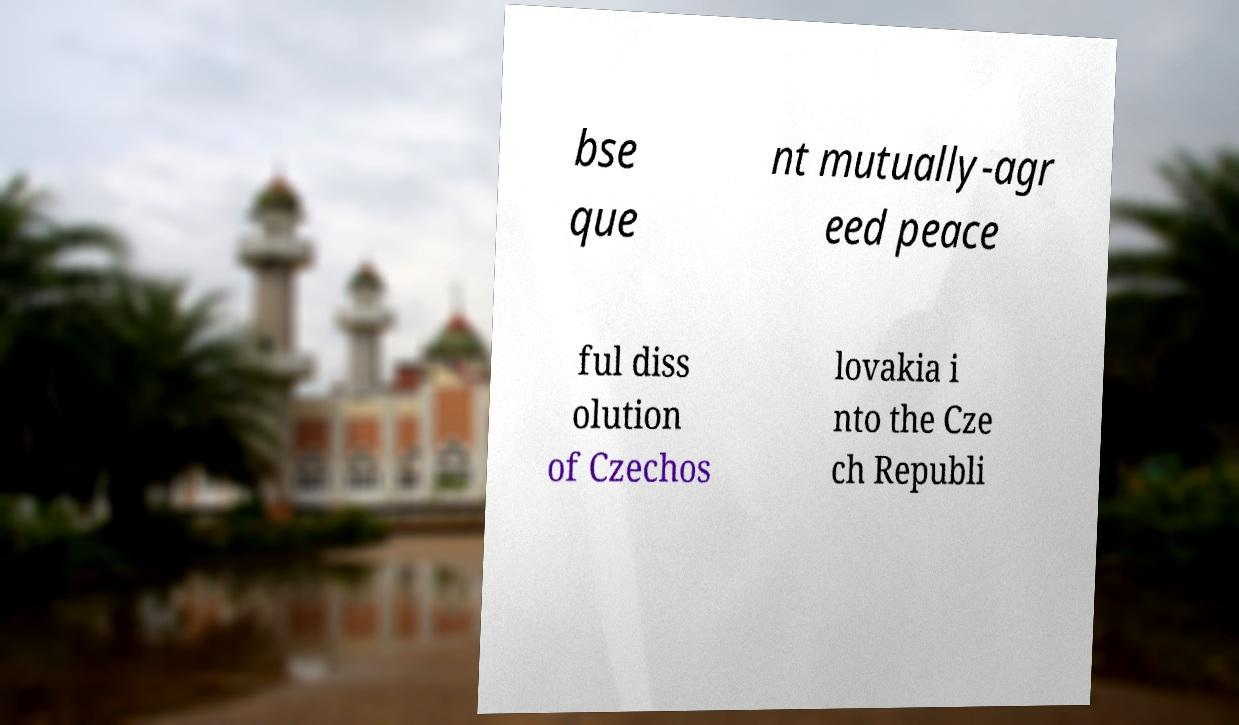Could you assist in decoding the text presented in this image and type it out clearly? bse que nt mutually-agr eed peace ful diss olution of Czechos lovakia i nto the Cze ch Republi 